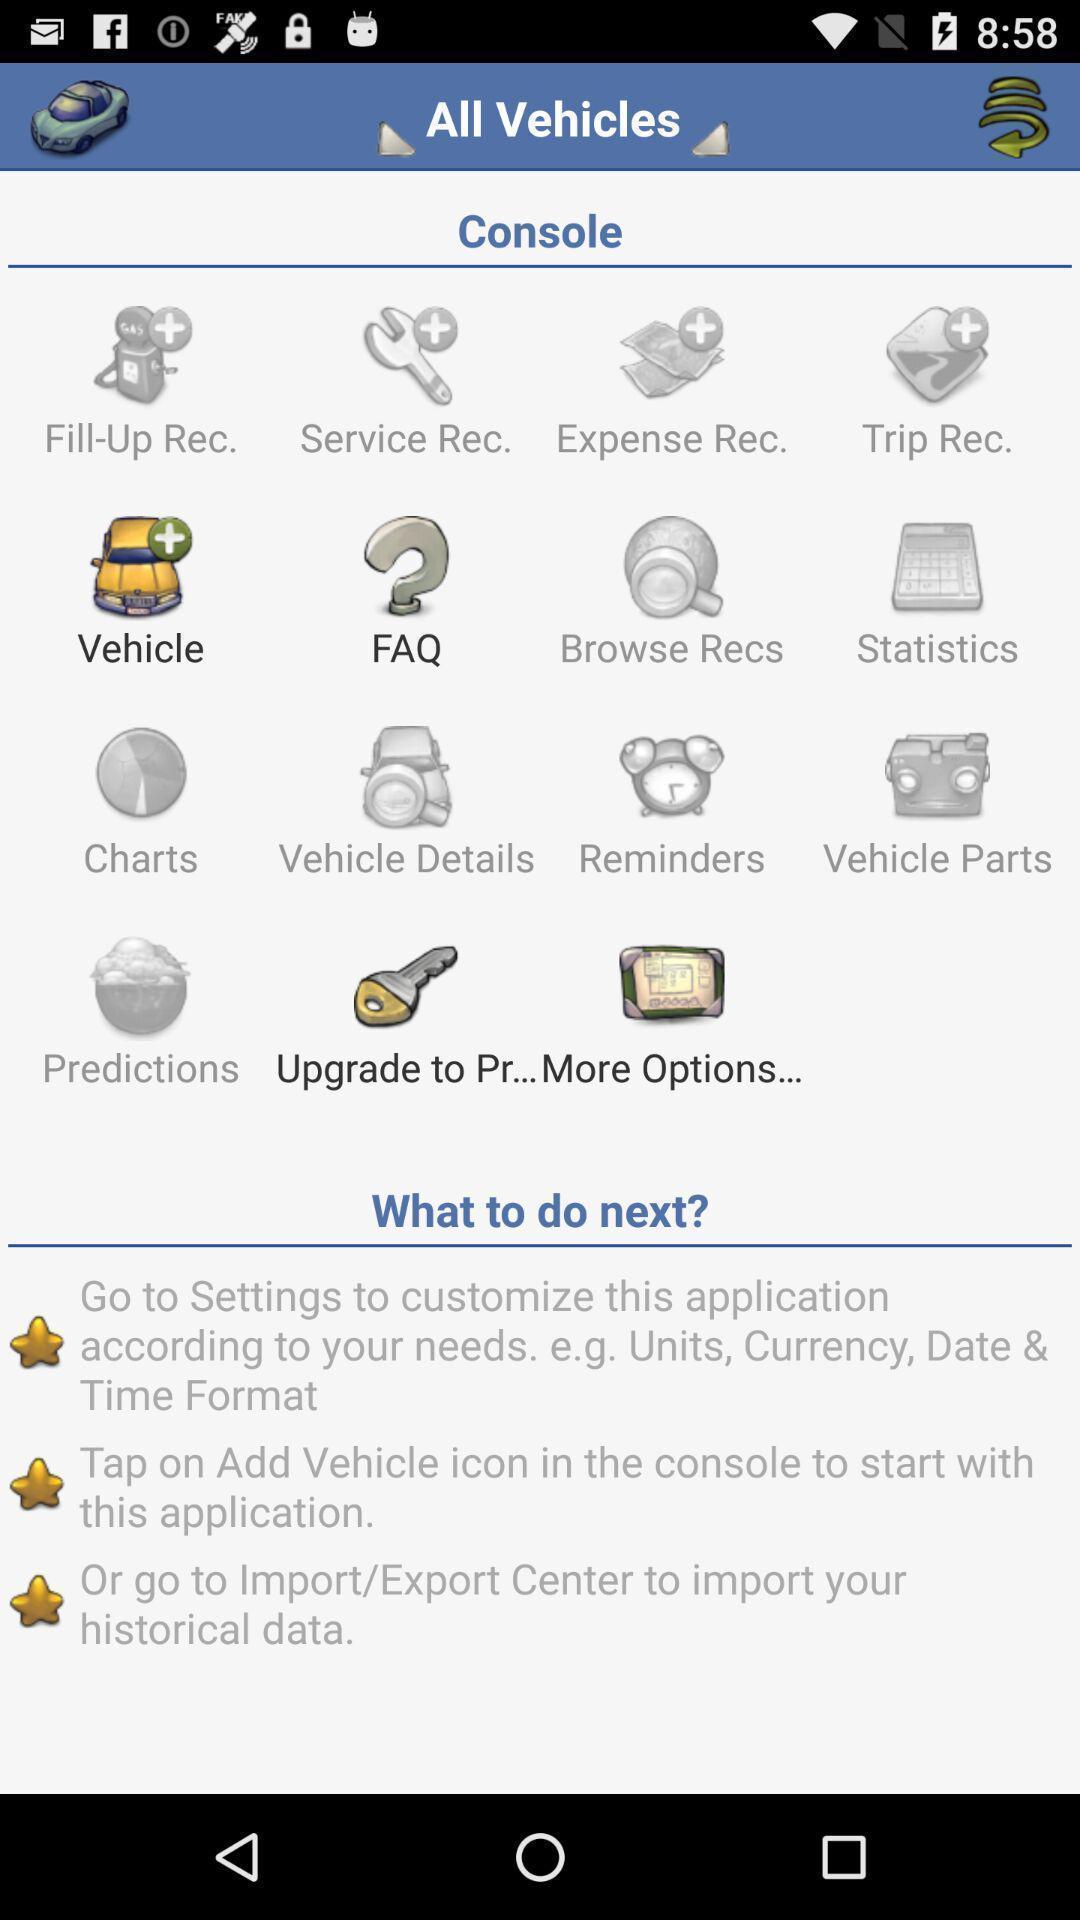What details can you identify in this image? Page shows the all vehicles console categories list. 